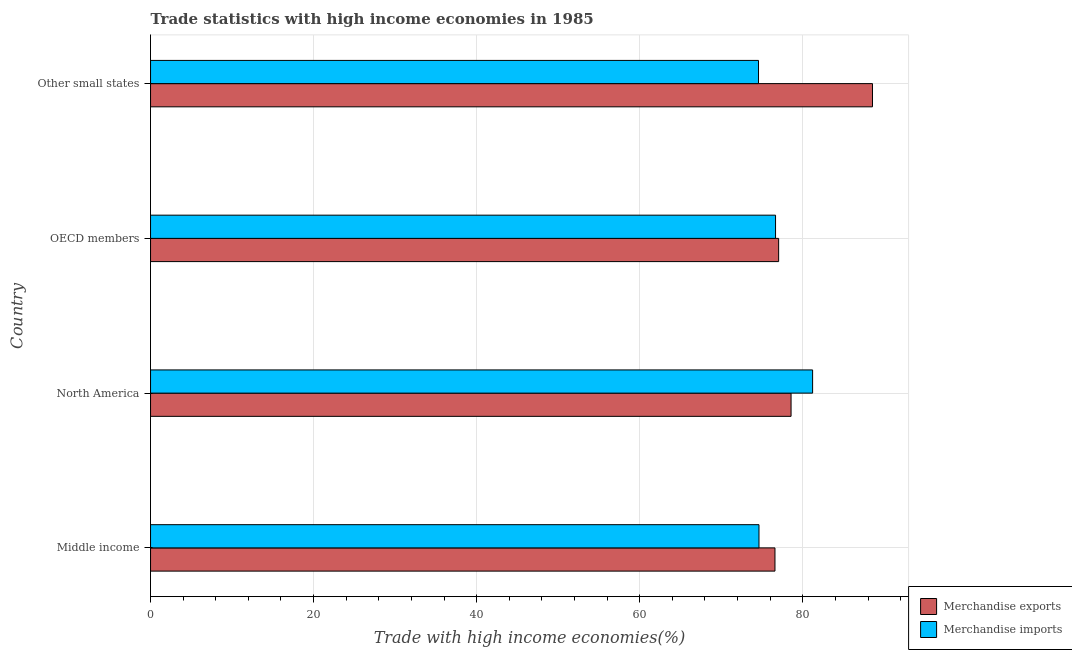How many different coloured bars are there?
Your answer should be compact. 2. Are the number of bars per tick equal to the number of legend labels?
Give a very brief answer. Yes. Are the number of bars on each tick of the Y-axis equal?
Your answer should be very brief. Yes. What is the label of the 1st group of bars from the top?
Make the answer very short. Other small states. What is the merchandise exports in Other small states?
Keep it short and to the point. 88.55. Across all countries, what is the maximum merchandise imports?
Provide a short and direct response. 81.2. Across all countries, what is the minimum merchandise exports?
Offer a very short reply. 76.59. In which country was the merchandise imports maximum?
Your answer should be very brief. North America. In which country was the merchandise imports minimum?
Your answer should be very brief. Other small states. What is the total merchandise exports in the graph?
Provide a succinct answer. 320.73. What is the difference between the merchandise exports in North America and that in Other small states?
Provide a short and direct response. -9.99. What is the difference between the merchandise exports in North America and the merchandise imports in Other small states?
Provide a succinct answer. 3.99. What is the average merchandise exports per country?
Your answer should be very brief. 80.18. What is the difference between the merchandise exports and merchandise imports in OECD members?
Give a very brief answer. 0.38. In how many countries, is the merchandise imports greater than 80 %?
Your answer should be very brief. 1. What is the ratio of the merchandise imports in Middle income to that in North America?
Make the answer very short. 0.92. Is the difference between the merchandise imports in North America and OECD members greater than the difference between the merchandise exports in North America and OECD members?
Your answer should be compact. Yes. What is the difference between the highest and the second highest merchandise exports?
Provide a succinct answer. 9.99. What is the difference between the highest and the lowest merchandise imports?
Give a very brief answer. 6.64. In how many countries, is the merchandise imports greater than the average merchandise imports taken over all countries?
Your answer should be very brief. 1. Is the sum of the merchandise exports in North America and OECD members greater than the maximum merchandise imports across all countries?
Make the answer very short. Yes. What does the 1st bar from the bottom in Other small states represents?
Your answer should be very brief. Merchandise exports. How many bars are there?
Your answer should be very brief. 8. What is the difference between two consecutive major ticks on the X-axis?
Provide a short and direct response. 20. Are the values on the major ticks of X-axis written in scientific E-notation?
Keep it short and to the point. No. Does the graph contain grids?
Your answer should be very brief. Yes. How are the legend labels stacked?
Ensure brevity in your answer.  Vertical. What is the title of the graph?
Make the answer very short. Trade statistics with high income economies in 1985. Does "From World Bank" appear as one of the legend labels in the graph?
Your answer should be very brief. No. What is the label or title of the X-axis?
Your answer should be compact. Trade with high income economies(%). What is the label or title of the Y-axis?
Offer a very short reply. Country. What is the Trade with high income economies(%) in Merchandise exports in Middle income?
Keep it short and to the point. 76.59. What is the Trade with high income economies(%) of Merchandise imports in Middle income?
Your answer should be very brief. 74.62. What is the Trade with high income economies(%) of Merchandise exports in North America?
Keep it short and to the point. 78.56. What is the Trade with high income economies(%) in Merchandise imports in North America?
Provide a short and direct response. 81.2. What is the Trade with high income economies(%) of Merchandise exports in OECD members?
Keep it short and to the point. 77.04. What is the Trade with high income economies(%) in Merchandise imports in OECD members?
Your response must be concise. 76.66. What is the Trade with high income economies(%) in Merchandise exports in Other small states?
Offer a very short reply. 88.55. What is the Trade with high income economies(%) of Merchandise imports in Other small states?
Provide a succinct answer. 74.57. Across all countries, what is the maximum Trade with high income economies(%) in Merchandise exports?
Provide a short and direct response. 88.55. Across all countries, what is the maximum Trade with high income economies(%) of Merchandise imports?
Your answer should be very brief. 81.2. Across all countries, what is the minimum Trade with high income economies(%) of Merchandise exports?
Your response must be concise. 76.59. Across all countries, what is the minimum Trade with high income economies(%) of Merchandise imports?
Your response must be concise. 74.57. What is the total Trade with high income economies(%) of Merchandise exports in the graph?
Make the answer very short. 320.73. What is the total Trade with high income economies(%) of Merchandise imports in the graph?
Ensure brevity in your answer.  307.05. What is the difference between the Trade with high income economies(%) in Merchandise exports in Middle income and that in North America?
Provide a succinct answer. -1.97. What is the difference between the Trade with high income economies(%) of Merchandise imports in Middle income and that in North America?
Make the answer very short. -6.58. What is the difference between the Trade with high income economies(%) in Merchandise exports in Middle income and that in OECD members?
Ensure brevity in your answer.  -0.45. What is the difference between the Trade with high income economies(%) in Merchandise imports in Middle income and that in OECD members?
Give a very brief answer. -2.03. What is the difference between the Trade with high income economies(%) of Merchandise exports in Middle income and that in Other small states?
Provide a succinct answer. -11.96. What is the difference between the Trade with high income economies(%) in Merchandise imports in Middle income and that in Other small states?
Your response must be concise. 0.06. What is the difference between the Trade with high income economies(%) in Merchandise exports in North America and that in OECD members?
Provide a succinct answer. 1.52. What is the difference between the Trade with high income economies(%) of Merchandise imports in North America and that in OECD members?
Offer a terse response. 4.55. What is the difference between the Trade with high income economies(%) of Merchandise exports in North America and that in Other small states?
Ensure brevity in your answer.  -9.99. What is the difference between the Trade with high income economies(%) of Merchandise imports in North America and that in Other small states?
Your answer should be very brief. 6.64. What is the difference between the Trade with high income economies(%) of Merchandise exports in OECD members and that in Other small states?
Offer a very short reply. -11.51. What is the difference between the Trade with high income economies(%) of Merchandise imports in OECD members and that in Other small states?
Offer a very short reply. 2.09. What is the difference between the Trade with high income economies(%) of Merchandise exports in Middle income and the Trade with high income economies(%) of Merchandise imports in North America?
Provide a succinct answer. -4.62. What is the difference between the Trade with high income economies(%) in Merchandise exports in Middle income and the Trade with high income economies(%) in Merchandise imports in OECD members?
Keep it short and to the point. -0.07. What is the difference between the Trade with high income economies(%) in Merchandise exports in Middle income and the Trade with high income economies(%) in Merchandise imports in Other small states?
Your answer should be compact. 2.02. What is the difference between the Trade with high income economies(%) of Merchandise exports in North America and the Trade with high income economies(%) of Merchandise imports in OECD members?
Your answer should be compact. 1.9. What is the difference between the Trade with high income economies(%) of Merchandise exports in North America and the Trade with high income economies(%) of Merchandise imports in Other small states?
Your response must be concise. 3.99. What is the difference between the Trade with high income economies(%) of Merchandise exports in OECD members and the Trade with high income economies(%) of Merchandise imports in Other small states?
Your response must be concise. 2.47. What is the average Trade with high income economies(%) of Merchandise exports per country?
Keep it short and to the point. 80.18. What is the average Trade with high income economies(%) in Merchandise imports per country?
Keep it short and to the point. 76.76. What is the difference between the Trade with high income economies(%) in Merchandise exports and Trade with high income economies(%) in Merchandise imports in Middle income?
Your response must be concise. 1.96. What is the difference between the Trade with high income economies(%) of Merchandise exports and Trade with high income economies(%) of Merchandise imports in North America?
Ensure brevity in your answer.  -2.64. What is the difference between the Trade with high income economies(%) of Merchandise exports and Trade with high income economies(%) of Merchandise imports in OECD members?
Your answer should be very brief. 0.38. What is the difference between the Trade with high income economies(%) in Merchandise exports and Trade with high income economies(%) in Merchandise imports in Other small states?
Give a very brief answer. 13.98. What is the ratio of the Trade with high income economies(%) in Merchandise exports in Middle income to that in North America?
Make the answer very short. 0.97. What is the ratio of the Trade with high income economies(%) in Merchandise imports in Middle income to that in North America?
Offer a very short reply. 0.92. What is the ratio of the Trade with high income economies(%) of Merchandise exports in Middle income to that in OECD members?
Ensure brevity in your answer.  0.99. What is the ratio of the Trade with high income economies(%) of Merchandise imports in Middle income to that in OECD members?
Make the answer very short. 0.97. What is the ratio of the Trade with high income economies(%) in Merchandise exports in Middle income to that in Other small states?
Your answer should be compact. 0.86. What is the ratio of the Trade with high income economies(%) in Merchandise imports in Middle income to that in Other small states?
Keep it short and to the point. 1. What is the ratio of the Trade with high income economies(%) in Merchandise exports in North America to that in OECD members?
Provide a short and direct response. 1.02. What is the ratio of the Trade with high income economies(%) of Merchandise imports in North America to that in OECD members?
Offer a terse response. 1.06. What is the ratio of the Trade with high income economies(%) of Merchandise exports in North America to that in Other small states?
Ensure brevity in your answer.  0.89. What is the ratio of the Trade with high income economies(%) of Merchandise imports in North America to that in Other small states?
Ensure brevity in your answer.  1.09. What is the ratio of the Trade with high income economies(%) in Merchandise exports in OECD members to that in Other small states?
Your answer should be very brief. 0.87. What is the ratio of the Trade with high income economies(%) in Merchandise imports in OECD members to that in Other small states?
Your response must be concise. 1.03. What is the difference between the highest and the second highest Trade with high income economies(%) of Merchandise exports?
Give a very brief answer. 9.99. What is the difference between the highest and the second highest Trade with high income economies(%) of Merchandise imports?
Offer a terse response. 4.55. What is the difference between the highest and the lowest Trade with high income economies(%) of Merchandise exports?
Offer a terse response. 11.96. What is the difference between the highest and the lowest Trade with high income economies(%) in Merchandise imports?
Keep it short and to the point. 6.64. 